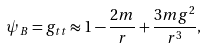<formula> <loc_0><loc_0><loc_500><loc_500>\psi _ { B } = g _ { t t } \approx 1 - \frac { 2 m } { r } + \frac { 3 m g ^ { 2 } } { r ^ { 3 } } ,</formula> 